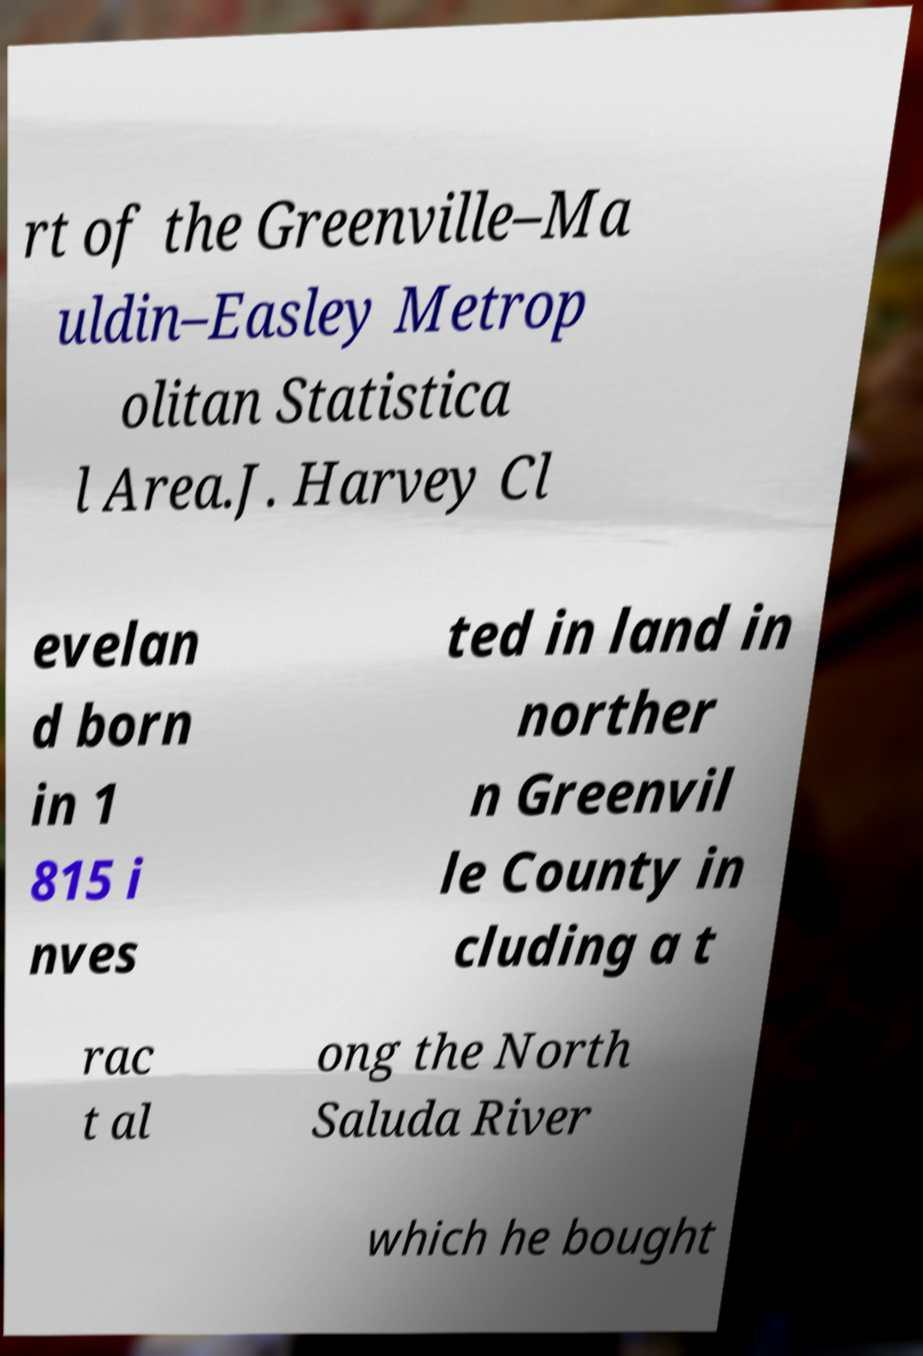Could you assist in decoding the text presented in this image and type it out clearly? rt of the Greenville–Ma uldin–Easley Metrop olitan Statistica l Area.J. Harvey Cl evelan d born in 1 815 i nves ted in land in norther n Greenvil le County in cluding a t rac t al ong the North Saluda River which he bought 